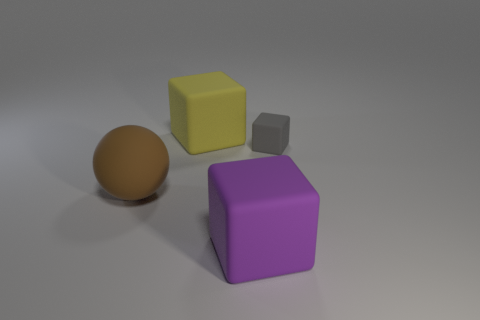Subtract all yellow rubber cubes. How many cubes are left? 2 Subtract 1 blocks. How many blocks are left? 2 Add 1 tiny red shiny things. How many objects exist? 5 Subtract all yellow cubes. How many cubes are left? 2 Subtract all blocks. How many objects are left? 1 Add 3 big things. How many big things are left? 6 Add 3 rubber cubes. How many rubber cubes exist? 6 Subtract 0 brown blocks. How many objects are left? 4 Subtract all blue spheres. Subtract all blue cubes. How many spheres are left? 1 Subtract all brown balls. How many blue blocks are left? 0 